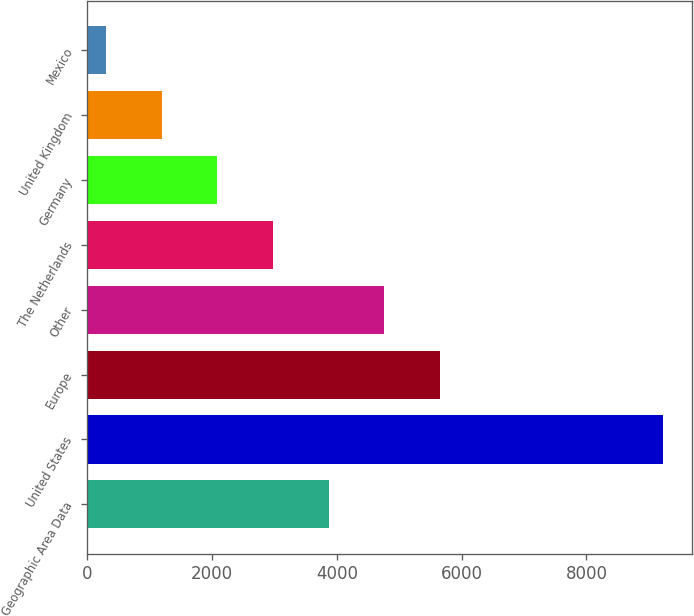<chart> <loc_0><loc_0><loc_500><loc_500><bar_chart><fcel>Geographic Area Data<fcel>United States<fcel>Europe<fcel>Other<fcel>The Netherlands<fcel>Germany<fcel>United Kingdom<fcel>Mexico<nl><fcel>3871.4<fcel>9221.3<fcel>5654.7<fcel>4763.05<fcel>2979.75<fcel>2088.1<fcel>1196.45<fcel>304.8<nl></chart> 